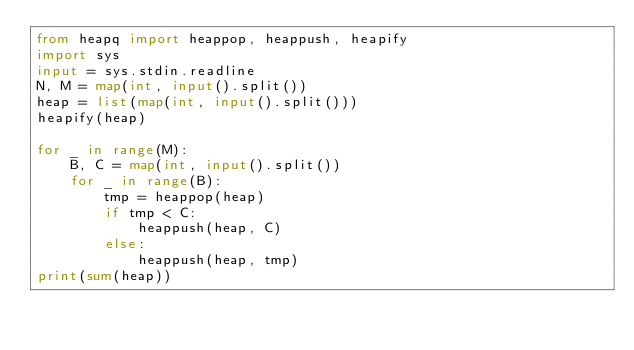Convert code to text. <code><loc_0><loc_0><loc_500><loc_500><_Python_>from heapq import heappop, heappush, heapify
import sys
input = sys.stdin.readline
N, M = map(int, input().split())
heap = list(map(int, input().split()))
heapify(heap)

for _ in range(M):
    B, C = map(int, input().split())
    for _ in range(B):
        tmp = heappop(heap)
        if tmp < C:
            heappush(heap, C)
        else:
            heappush(heap, tmp)
print(sum(heap))</code> 